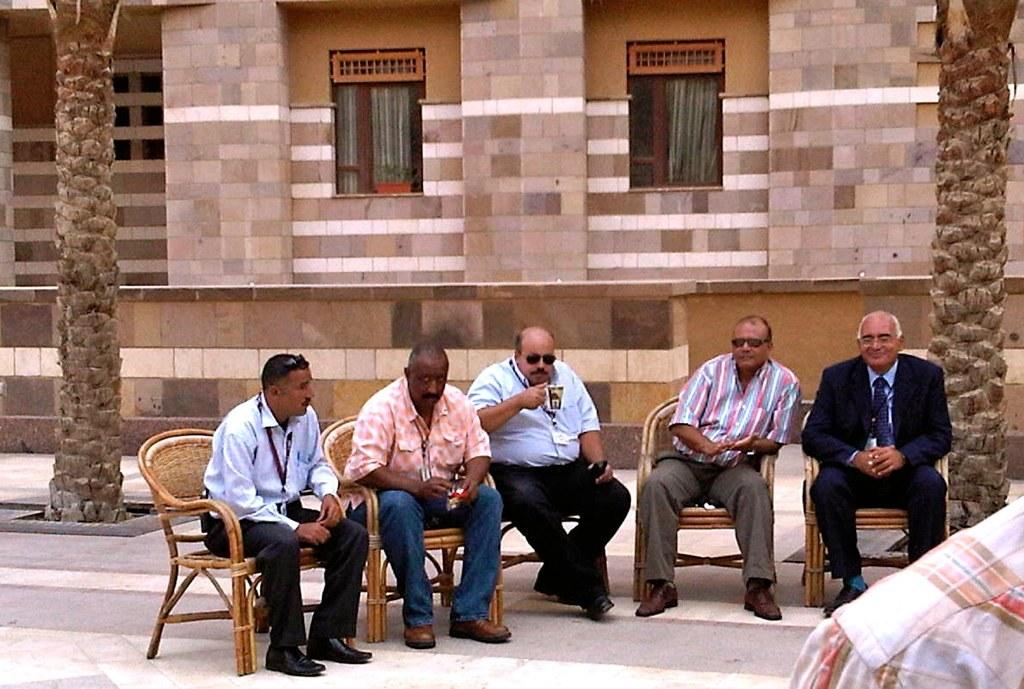What are the people in the image doing? There is a group of persons sitting in the image. What can be seen in the background of the image? There is a building and trees in the background of the image. What features can be observed on the building? There are windows in the building. What type of flock is flying over the group of persons in the image? There is no flock of birds or any other animals visible in the image. 